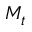<formula> <loc_0><loc_0><loc_500><loc_500>M _ { t }</formula> 